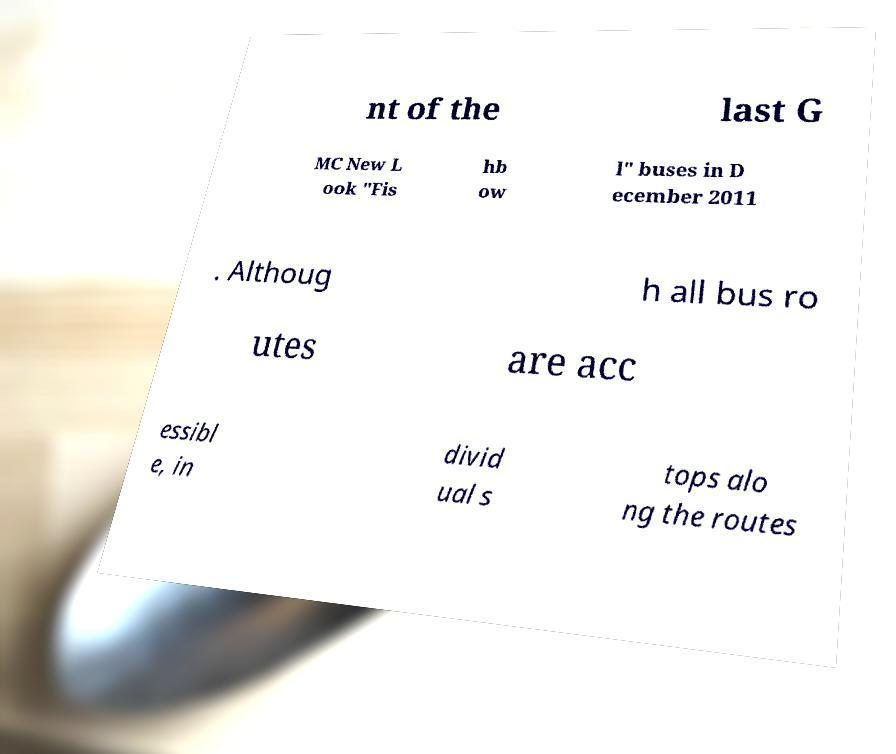Could you assist in decoding the text presented in this image and type it out clearly? nt of the last G MC New L ook "Fis hb ow l" buses in D ecember 2011 . Althoug h all bus ro utes are acc essibl e, in divid ual s tops alo ng the routes 